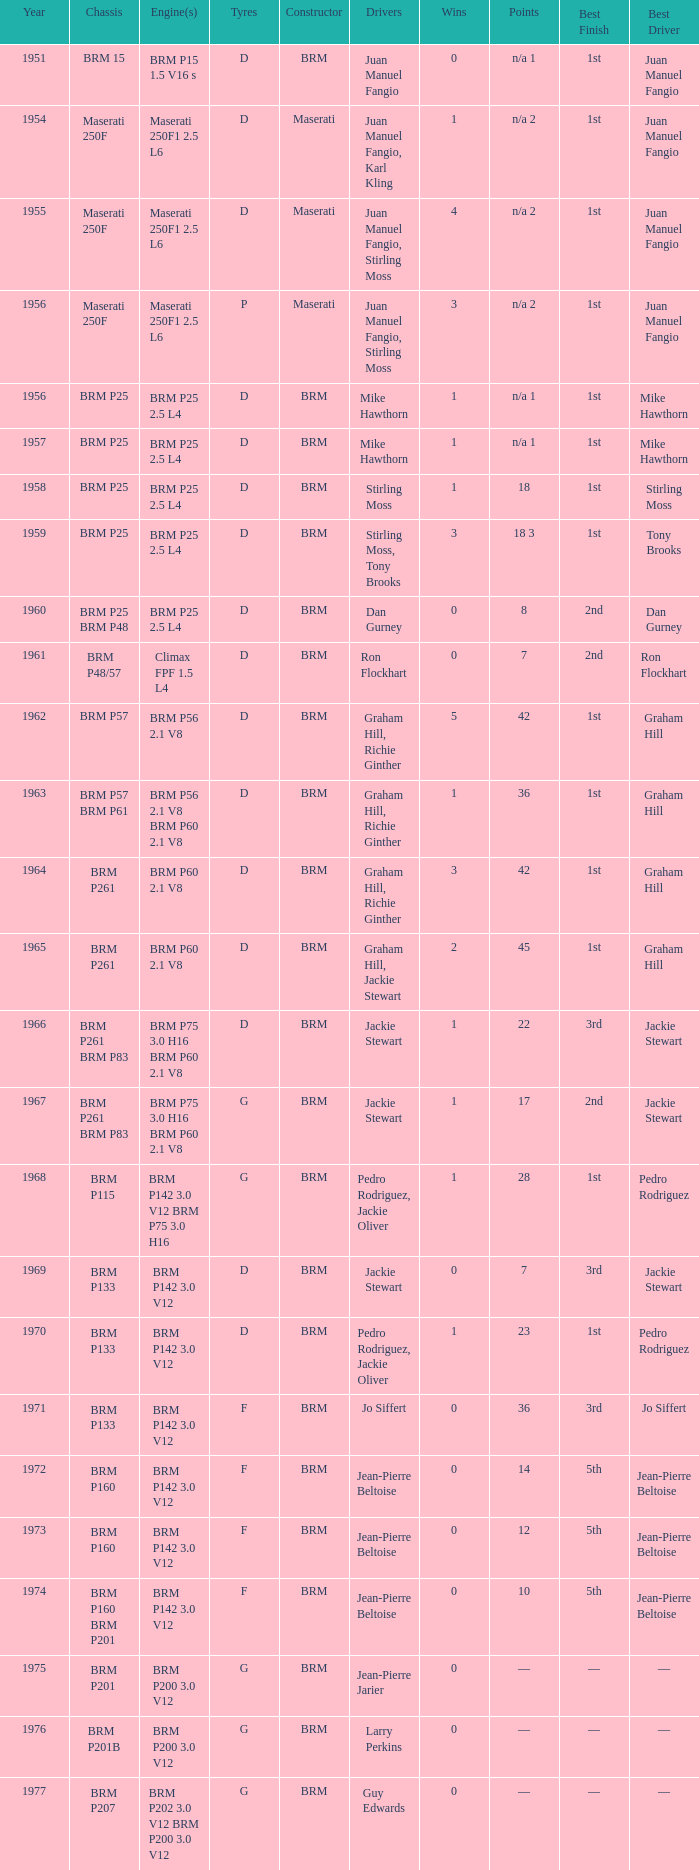Name the point for 1974 10.0. 